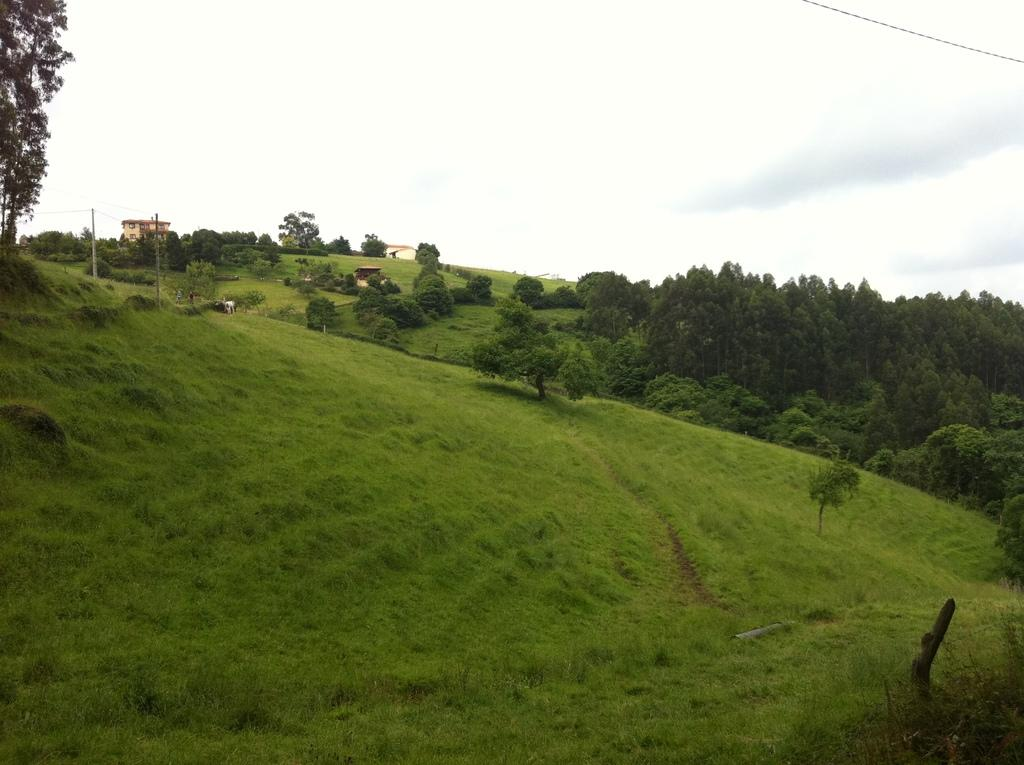What is the main setting of the image? There is a field in the image. What can be seen in the background of the field? There are trees and houses in the background of the image. What is the weather like in the image? The sky is cloudy in the image. Who is the manager of the cake in the image? There is no cake present in the image, so there is no manager for a cake. 